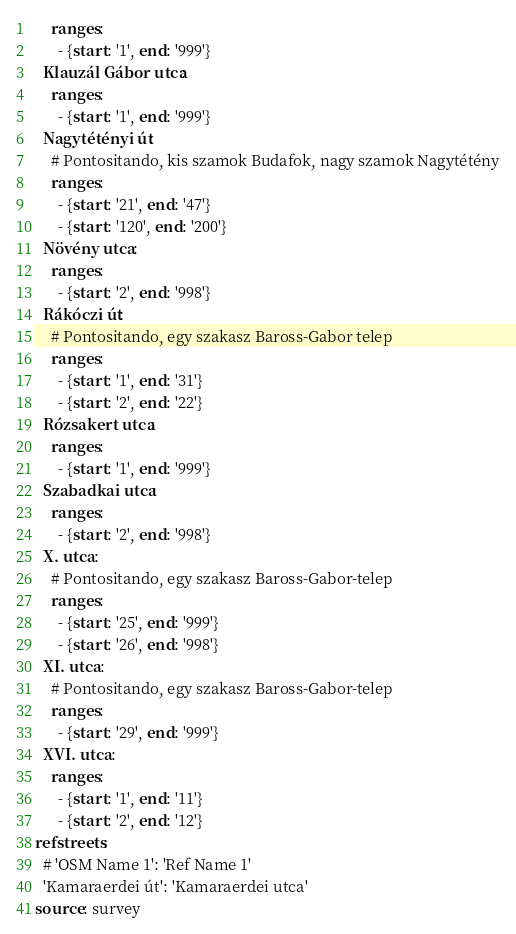Convert code to text. <code><loc_0><loc_0><loc_500><loc_500><_YAML_>    ranges:
      - {start: '1', end: '999'}
  Klauzál Gábor utca:
    ranges:
      - {start: '1', end: '999'}
  Nagytétényi út:
    # Pontositando, kis szamok Budafok, nagy szamok Nagytétény
    ranges:
      - {start: '21', end: '47'}
      - {start: '120', end: '200'}
  Növény utca:
    ranges:
      - {start: '2', end: '998'}
  Rákóczi út:
    # Pontositando, egy szakasz Baross-Gabor telep
    ranges:
      - {start: '1', end: '31'}
      - {start: '2', end: '22'}
  Rózsakert utca:
    ranges:
      - {start: '1', end: '999'}
  Szabadkai utca:
    ranges:
      - {start: '2', end: '998'}
  X. utca:
    # Pontositando, egy szakasz Baross-Gabor-telep
    ranges:
      - {start: '25', end: '999'}
      - {start: '26', end: '998'}
  XI. utca:
    # Pontositando, egy szakasz Baross-Gabor-telep
    ranges:
      - {start: '29', end: '999'}
  XVI. utca:
    ranges:
      - {start: '1', end: '11'}
      - {start: '2', end: '12'}
refstreets:
  # 'OSM Name 1': 'Ref Name 1'
  'Kamaraerdei út': 'Kamaraerdei utca'
source: survey
</code> 